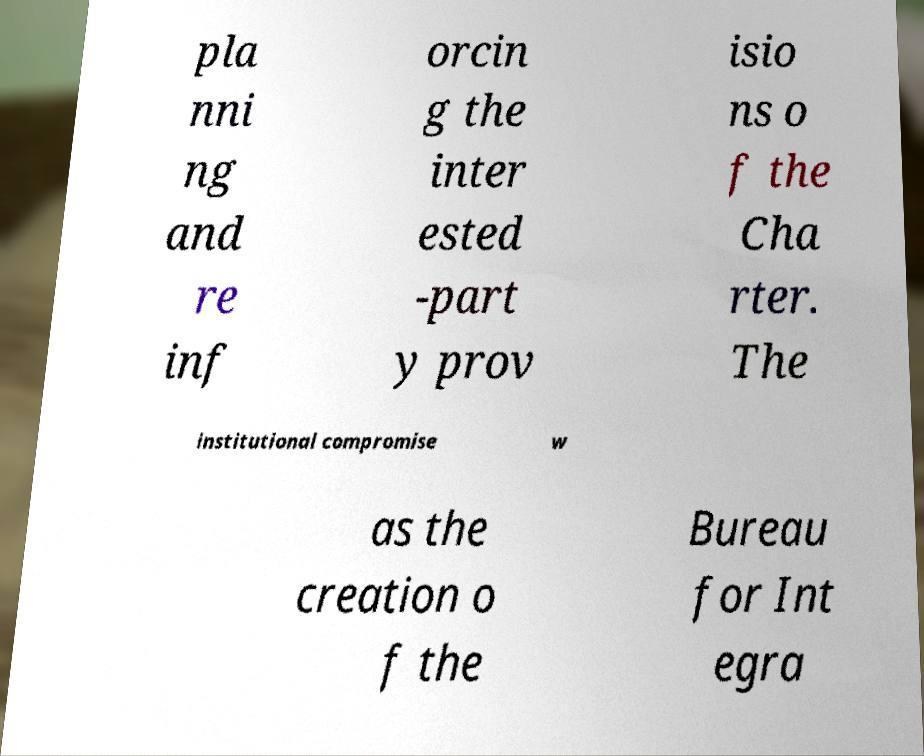Can you read and provide the text displayed in the image?This photo seems to have some interesting text. Can you extract and type it out for me? pla nni ng and re inf orcin g the inter ested -part y prov isio ns o f the Cha rter. The institutional compromise w as the creation o f the Bureau for Int egra 